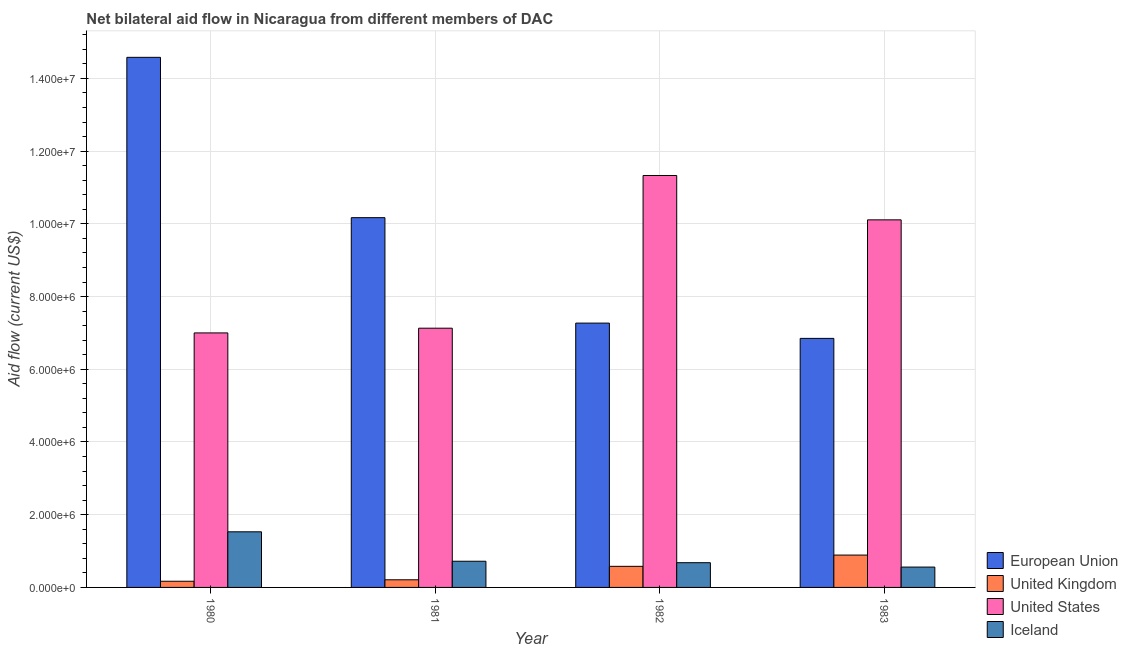How many different coloured bars are there?
Offer a terse response. 4. How many bars are there on the 3rd tick from the left?
Your answer should be compact. 4. How many bars are there on the 1st tick from the right?
Your answer should be very brief. 4. What is the label of the 3rd group of bars from the left?
Offer a terse response. 1982. What is the amount of aid given by us in 1982?
Keep it short and to the point. 1.13e+07. Across all years, what is the maximum amount of aid given by eu?
Provide a short and direct response. 1.46e+07. Across all years, what is the minimum amount of aid given by iceland?
Offer a very short reply. 5.60e+05. In which year was the amount of aid given by uk maximum?
Offer a terse response. 1983. What is the total amount of aid given by us in the graph?
Make the answer very short. 3.56e+07. What is the difference between the amount of aid given by uk in 1981 and that in 1983?
Ensure brevity in your answer.  -6.80e+05. What is the difference between the amount of aid given by iceland in 1983 and the amount of aid given by eu in 1982?
Make the answer very short. -1.20e+05. What is the average amount of aid given by eu per year?
Your answer should be very brief. 9.72e+06. In the year 1980, what is the difference between the amount of aid given by uk and amount of aid given by us?
Keep it short and to the point. 0. What is the ratio of the amount of aid given by iceland in 1981 to that in 1982?
Offer a terse response. 1.06. Is the amount of aid given by iceland in 1980 less than that in 1981?
Offer a very short reply. No. What is the difference between the highest and the second highest amount of aid given by us?
Your answer should be compact. 1.22e+06. What is the difference between the highest and the lowest amount of aid given by uk?
Give a very brief answer. 7.20e+05. Is the sum of the amount of aid given by eu in 1980 and 1981 greater than the maximum amount of aid given by iceland across all years?
Make the answer very short. Yes. How many bars are there?
Keep it short and to the point. 16. What is the difference between two consecutive major ticks on the Y-axis?
Offer a terse response. 2.00e+06. Does the graph contain any zero values?
Your answer should be compact. No. How are the legend labels stacked?
Offer a terse response. Vertical. What is the title of the graph?
Keep it short and to the point. Net bilateral aid flow in Nicaragua from different members of DAC. Does "Efficiency of custom clearance process" appear as one of the legend labels in the graph?
Offer a very short reply. No. What is the label or title of the X-axis?
Your response must be concise. Year. What is the Aid flow (current US$) of European Union in 1980?
Provide a short and direct response. 1.46e+07. What is the Aid flow (current US$) of Iceland in 1980?
Your answer should be compact. 1.53e+06. What is the Aid flow (current US$) of European Union in 1981?
Your answer should be very brief. 1.02e+07. What is the Aid flow (current US$) of United Kingdom in 1981?
Offer a very short reply. 2.10e+05. What is the Aid flow (current US$) in United States in 1981?
Provide a succinct answer. 7.13e+06. What is the Aid flow (current US$) of Iceland in 1981?
Provide a short and direct response. 7.20e+05. What is the Aid flow (current US$) in European Union in 1982?
Your response must be concise. 7.27e+06. What is the Aid flow (current US$) in United Kingdom in 1982?
Offer a terse response. 5.80e+05. What is the Aid flow (current US$) in United States in 1982?
Provide a short and direct response. 1.13e+07. What is the Aid flow (current US$) in Iceland in 1982?
Keep it short and to the point. 6.80e+05. What is the Aid flow (current US$) of European Union in 1983?
Keep it short and to the point. 6.85e+06. What is the Aid flow (current US$) in United Kingdom in 1983?
Offer a terse response. 8.90e+05. What is the Aid flow (current US$) in United States in 1983?
Your answer should be compact. 1.01e+07. What is the Aid flow (current US$) in Iceland in 1983?
Make the answer very short. 5.60e+05. Across all years, what is the maximum Aid flow (current US$) in European Union?
Provide a short and direct response. 1.46e+07. Across all years, what is the maximum Aid flow (current US$) of United Kingdom?
Your response must be concise. 8.90e+05. Across all years, what is the maximum Aid flow (current US$) in United States?
Provide a succinct answer. 1.13e+07. Across all years, what is the maximum Aid flow (current US$) of Iceland?
Ensure brevity in your answer.  1.53e+06. Across all years, what is the minimum Aid flow (current US$) of European Union?
Make the answer very short. 6.85e+06. Across all years, what is the minimum Aid flow (current US$) in Iceland?
Your answer should be very brief. 5.60e+05. What is the total Aid flow (current US$) in European Union in the graph?
Ensure brevity in your answer.  3.89e+07. What is the total Aid flow (current US$) of United Kingdom in the graph?
Your response must be concise. 1.85e+06. What is the total Aid flow (current US$) of United States in the graph?
Provide a short and direct response. 3.56e+07. What is the total Aid flow (current US$) of Iceland in the graph?
Offer a terse response. 3.49e+06. What is the difference between the Aid flow (current US$) in European Union in 1980 and that in 1981?
Your response must be concise. 4.41e+06. What is the difference between the Aid flow (current US$) of United States in 1980 and that in 1981?
Your answer should be very brief. -1.30e+05. What is the difference between the Aid flow (current US$) in Iceland in 1980 and that in 1981?
Offer a terse response. 8.10e+05. What is the difference between the Aid flow (current US$) in European Union in 1980 and that in 1982?
Your response must be concise. 7.31e+06. What is the difference between the Aid flow (current US$) in United Kingdom in 1980 and that in 1982?
Your response must be concise. -4.10e+05. What is the difference between the Aid flow (current US$) of United States in 1980 and that in 1982?
Your answer should be compact. -4.33e+06. What is the difference between the Aid flow (current US$) in Iceland in 1980 and that in 1982?
Provide a short and direct response. 8.50e+05. What is the difference between the Aid flow (current US$) in European Union in 1980 and that in 1983?
Keep it short and to the point. 7.73e+06. What is the difference between the Aid flow (current US$) of United Kingdom in 1980 and that in 1983?
Your response must be concise. -7.20e+05. What is the difference between the Aid flow (current US$) in United States in 1980 and that in 1983?
Your answer should be compact. -3.11e+06. What is the difference between the Aid flow (current US$) of Iceland in 1980 and that in 1983?
Your response must be concise. 9.70e+05. What is the difference between the Aid flow (current US$) in European Union in 1981 and that in 1982?
Keep it short and to the point. 2.90e+06. What is the difference between the Aid flow (current US$) of United Kingdom in 1981 and that in 1982?
Your response must be concise. -3.70e+05. What is the difference between the Aid flow (current US$) of United States in 1981 and that in 1982?
Make the answer very short. -4.20e+06. What is the difference between the Aid flow (current US$) of European Union in 1981 and that in 1983?
Make the answer very short. 3.32e+06. What is the difference between the Aid flow (current US$) in United Kingdom in 1981 and that in 1983?
Provide a short and direct response. -6.80e+05. What is the difference between the Aid flow (current US$) in United States in 1981 and that in 1983?
Your answer should be very brief. -2.98e+06. What is the difference between the Aid flow (current US$) in Iceland in 1981 and that in 1983?
Give a very brief answer. 1.60e+05. What is the difference between the Aid flow (current US$) of European Union in 1982 and that in 1983?
Provide a short and direct response. 4.20e+05. What is the difference between the Aid flow (current US$) of United Kingdom in 1982 and that in 1983?
Provide a short and direct response. -3.10e+05. What is the difference between the Aid flow (current US$) of United States in 1982 and that in 1983?
Offer a terse response. 1.22e+06. What is the difference between the Aid flow (current US$) of European Union in 1980 and the Aid flow (current US$) of United Kingdom in 1981?
Offer a terse response. 1.44e+07. What is the difference between the Aid flow (current US$) of European Union in 1980 and the Aid flow (current US$) of United States in 1981?
Keep it short and to the point. 7.45e+06. What is the difference between the Aid flow (current US$) of European Union in 1980 and the Aid flow (current US$) of Iceland in 1981?
Your answer should be very brief. 1.39e+07. What is the difference between the Aid flow (current US$) of United Kingdom in 1980 and the Aid flow (current US$) of United States in 1981?
Your answer should be very brief. -6.96e+06. What is the difference between the Aid flow (current US$) in United Kingdom in 1980 and the Aid flow (current US$) in Iceland in 1981?
Offer a terse response. -5.50e+05. What is the difference between the Aid flow (current US$) in United States in 1980 and the Aid flow (current US$) in Iceland in 1981?
Provide a short and direct response. 6.28e+06. What is the difference between the Aid flow (current US$) in European Union in 1980 and the Aid flow (current US$) in United Kingdom in 1982?
Keep it short and to the point. 1.40e+07. What is the difference between the Aid flow (current US$) in European Union in 1980 and the Aid flow (current US$) in United States in 1982?
Provide a short and direct response. 3.25e+06. What is the difference between the Aid flow (current US$) of European Union in 1980 and the Aid flow (current US$) of Iceland in 1982?
Your answer should be compact. 1.39e+07. What is the difference between the Aid flow (current US$) of United Kingdom in 1980 and the Aid flow (current US$) of United States in 1982?
Ensure brevity in your answer.  -1.12e+07. What is the difference between the Aid flow (current US$) in United Kingdom in 1980 and the Aid flow (current US$) in Iceland in 1982?
Keep it short and to the point. -5.10e+05. What is the difference between the Aid flow (current US$) in United States in 1980 and the Aid flow (current US$) in Iceland in 1982?
Provide a short and direct response. 6.32e+06. What is the difference between the Aid flow (current US$) in European Union in 1980 and the Aid flow (current US$) in United Kingdom in 1983?
Offer a terse response. 1.37e+07. What is the difference between the Aid flow (current US$) in European Union in 1980 and the Aid flow (current US$) in United States in 1983?
Your response must be concise. 4.47e+06. What is the difference between the Aid flow (current US$) in European Union in 1980 and the Aid flow (current US$) in Iceland in 1983?
Provide a short and direct response. 1.40e+07. What is the difference between the Aid flow (current US$) of United Kingdom in 1980 and the Aid flow (current US$) of United States in 1983?
Offer a very short reply. -9.94e+06. What is the difference between the Aid flow (current US$) in United Kingdom in 1980 and the Aid flow (current US$) in Iceland in 1983?
Your answer should be compact. -3.90e+05. What is the difference between the Aid flow (current US$) of United States in 1980 and the Aid flow (current US$) of Iceland in 1983?
Offer a very short reply. 6.44e+06. What is the difference between the Aid flow (current US$) of European Union in 1981 and the Aid flow (current US$) of United Kingdom in 1982?
Give a very brief answer. 9.59e+06. What is the difference between the Aid flow (current US$) in European Union in 1981 and the Aid flow (current US$) in United States in 1982?
Your answer should be very brief. -1.16e+06. What is the difference between the Aid flow (current US$) in European Union in 1981 and the Aid flow (current US$) in Iceland in 1982?
Ensure brevity in your answer.  9.49e+06. What is the difference between the Aid flow (current US$) in United Kingdom in 1981 and the Aid flow (current US$) in United States in 1982?
Keep it short and to the point. -1.11e+07. What is the difference between the Aid flow (current US$) in United Kingdom in 1981 and the Aid flow (current US$) in Iceland in 1982?
Ensure brevity in your answer.  -4.70e+05. What is the difference between the Aid flow (current US$) of United States in 1981 and the Aid flow (current US$) of Iceland in 1982?
Offer a very short reply. 6.45e+06. What is the difference between the Aid flow (current US$) of European Union in 1981 and the Aid flow (current US$) of United Kingdom in 1983?
Make the answer very short. 9.28e+06. What is the difference between the Aid flow (current US$) of European Union in 1981 and the Aid flow (current US$) of Iceland in 1983?
Ensure brevity in your answer.  9.61e+06. What is the difference between the Aid flow (current US$) in United Kingdom in 1981 and the Aid flow (current US$) in United States in 1983?
Ensure brevity in your answer.  -9.90e+06. What is the difference between the Aid flow (current US$) in United Kingdom in 1981 and the Aid flow (current US$) in Iceland in 1983?
Offer a very short reply. -3.50e+05. What is the difference between the Aid flow (current US$) of United States in 1981 and the Aid flow (current US$) of Iceland in 1983?
Keep it short and to the point. 6.57e+06. What is the difference between the Aid flow (current US$) of European Union in 1982 and the Aid flow (current US$) of United Kingdom in 1983?
Offer a terse response. 6.38e+06. What is the difference between the Aid flow (current US$) of European Union in 1982 and the Aid flow (current US$) of United States in 1983?
Ensure brevity in your answer.  -2.84e+06. What is the difference between the Aid flow (current US$) in European Union in 1982 and the Aid flow (current US$) in Iceland in 1983?
Ensure brevity in your answer.  6.71e+06. What is the difference between the Aid flow (current US$) in United Kingdom in 1982 and the Aid flow (current US$) in United States in 1983?
Your answer should be very brief. -9.53e+06. What is the difference between the Aid flow (current US$) of United States in 1982 and the Aid flow (current US$) of Iceland in 1983?
Your response must be concise. 1.08e+07. What is the average Aid flow (current US$) in European Union per year?
Your answer should be compact. 9.72e+06. What is the average Aid flow (current US$) in United Kingdom per year?
Offer a very short reply. 4.62e+05. What is the average Aid flow (current US$) in United States per year?
Keep it short and to the point. 8.89e+06. What is the average Aid flow (current US$) in Iceland per year?
Ensure brevity in your answer.  8.72e+05. In the year 1980, what is the difference between the Aid flow (current US$) in European Union and Aid flow (current US$) in United Kingdom?
Your answer should be compact. 1.44e+07. In the year 1980, what is the difference between the Aid flow (current US$) of European Union and Aid flow (current US$) of United States?
Give a very brief answer. 7.58e+06. In the year 1980, what is the difference between the Aid flow (current US$) in European Union and Aid flow (current US$) in Iceland?
Offer a terse response. 1.30e+07. In the year 1980, what is the difference between the Aid flow (current US$) of United Kingdom and Aid flow (current US$) of United States?
Give a very brief answer. -6.83e+06. In the year 1980, what is the difference between the Aid flow (current US$) of United Kingdom and Aid flow (current US$) of Iceland?
Provide a short and direct response. -1.36e+06. In the year 1980, what is the difference between the Aid flow (current US$) in United States and Aid flow (current US$) in Iceland?
Make the answer very short. 5.47e+06. In the year 1981, what is the difference between the Aid flow (current US$) in European Union and Aid flow (current US$) in United Kingdom?
Offer a very short reply. 9.96e+06. In the year 1981, what is the difference between the Aid flow (current US$) in European Union and Aid flow (current US$) in United States?
Provide a short and direct response. 3.04e+06. In the year 1981, what is the difference between the Aid flow (current US$) of European Union and Aid flow (current US$) of Iceland?
Give a very brief answer. 9.45e+06. In the year 1981, what is the difference between the Aid flow (current US$) of United Kingdom and Aid flow (current US$) of United States?
Provide a short and direct response. -6.92e+06. In the year 1981, what is the difference between the Aid flow (current US$) of United Kingdom and Aid flow (current US$) of Iceland?
Provide a short and direct response. -5.10e+05. In the year 1981, what is the difference between the Aid flow (current US$) in United States and Aid flow (current US$) in Iceland?
Ensure brevity in your answer.  6.41e+06. In the year 1982, what is the difference between the Aid flow (current US$) of European Union and Aid flow (current US$) of United Kingdom?
Offer a terse response. 6.69e+06. In the year 1982, what is the difference between the Aid flow (current US$) in European Union and Aid flow (current US$) in United States?
Give a very brief answer. -4.06e+06. In the year 1982, what is the difference between the Aid flow (current US$) of European Union and Aid flow (current US$) of Iceland?
Your answer should be very brief. 6.59e+06. In the year 1982, what is the difference between the Aid flow (current US$) of United Kingdom and Aid flow (current US$) of United States?
Offer a terse response. -1.08e+07. In the year 1982, what is the difference between the Aid flow (current US$) of United States and Aid flow (current US$) of Iceland?
Ensure brevity in your answer.  1.06e+07. In the year 1983, what is the difference between the Aid flow (current US$) in European Union and Aid flow (current US$) in United Kingdom?
Ensure brevity in your answer.  5.96e+06. In the year 1983, what is the difference between the Aid flow (current US$) of European Union and Aid flow (current US$) of United States?
Offer a terse response. -3.26e+06. In the year 1983, what is the difference between the Aid flow (current US$) of European Union and Aid flow (current US$) of Iceland?
Provide a short and direct response. 6.29e+06. In the year 1983, what is the difference between the Aid flow (current US$) of United Kingdom and Aid flow (current US$) of United States?
Provide a succinct answer. -9.22e+06. In the year 1983, what is the difference between the Aid flow (current US$) of United Kingdom and Aid flow (current US$) of Iceland?
Offer a terse response. 3.30e+05. In the year 1983, what is the difference between the Aid flow (current US$) of United States and Aid flow (current US$) of Iceland?
Make the answer very short. 9.55e+06. What is the ratio of the Aid flow (current US$) of European Union in 1980 to that in 1981?
Your response must be concise. 1.43. What is the ratio of the Aid flow (current US$) of United Kingdom in 1980 to that in 1981?
Offer a terse response. 0.81. What is the ratio of the Aid flow (current US$) of United States in 1980 to that in 1981?
Your response must be concise. 0.98. What is the ratio of the Aid flow (current US$) of Iceland in 1980 to that in 1981?
Provide a succinct answer. 2.12. What is the ratio of the Aid flow (current US$) of European Union in 1980 to that in 1982?
Your answer should be very brief. 2.01. What is the ratio of the Aid flow (current US$) in United Kingdom in 1980 to that in 1982?
Provide a short and direct response. 0.29. What is the ratio of the Aid flow (current US$) of United States in 1980 to that in 1982?
Your response must be concise. 0.62. What is the ratio of the Aid flow (current US$) of Iceland in 1980 to that in 1982?
Offer a terse response. 2.25. What is the ratio of the Aid flow (current US$) of European Union in 1980 to that in 1983?
Give a very brief answer. 2.13. What is the ratio of the Aid flow (current US$) in United Kingdom in 1980 to that in 1983?
Offer a very short reply. 0.19. What is the ratio of the Aid flow (current US$) of United States in 1980 to that in 1983?
Make the answer very short. 0.69. What is the ratio of the Aid flow (current US$) in Iceland in 1980 to that in 1983?
Offer a terse response. 2.73. What is the ratio of the Aid flow (current US$) in European Union in 1981 to that in 1982?
Offer a terse response. 1.4. What is the ratio of the Aid flow (current US$) of United Kingdom in 1981 to that in 1982?
Give a very brief answer. 0.36. What is the ratio of the Aid flow (current US$) of United States in 1981 to that in 1982?
Give a very brief answer. 0.63. What is the ratio of the Aid flow (current US$) in Iceland in 1981 to that in 1982?
Your answer should be compact. 1.06. What is the ratio of the Aid flow (current US$) of European Union in 1981 to that in 1983?
Ensure brevity in your answer.  1.48. What is the ratio of the Aid flow (current US$) of United Kingdom in 1981 to that in 1983?
Make the answer very short. 0.24. What is the ratio of the Aid flow (current US$) of United States in 1981 to that in 1983?
Give a very brief answer. 0.71. What is the ratio of the Aid flow (current US$) in European Union in 1982 to that in 1983?
Make the answer very short. 1.06. What is the ratio of the Aid flow (current US$) in United Kingdom in 1982 to that in 1983?
Provide a short and direct response. 0.65. What is the ratio of the Aid flow (current US$) of United States in 1982 to that in 1983?
Your answer should be compact. 1.12. What is the ratio of the Aid flow (current US$) of Iceland in 1982 to that in 1983?
Keep it short and to the point. 1.21. What is the difference between the highest and the second highest Aid flow (current US$) in European Union?
Make the answer very short. 4.41e+06. What is the difference between the highest and the second highest Aid flow (current US$) of United Kingdom?
Keep it short and to the point. 3.10e+05. What is the difference between the highest and the second highest Aid flow (current US$) in United States?
Offer a very short reply. 1.22e+06. What is the difference between the highest and the second highest Aid flow (current US$) of Iceland?
Offer a terse response. 8.10e+05. What is the difference between the highest and the lowest Aid flow (current US$) of European Union?
Offer a terse response. 7.73e+06. What is the difference between the highest and the lowest Aid flow (current US$) in United Kingdom?
Offer a very short reply. 7.20e+05. What is the difference between the highest and the lowest Aid flow (current US$) in United States?
Provide a succinct answer. 4.33e+06. What is the difference between the highest and the lowest Aid flow (current US$) of Iceland?
Make the answer very short. 9.70e+05. 